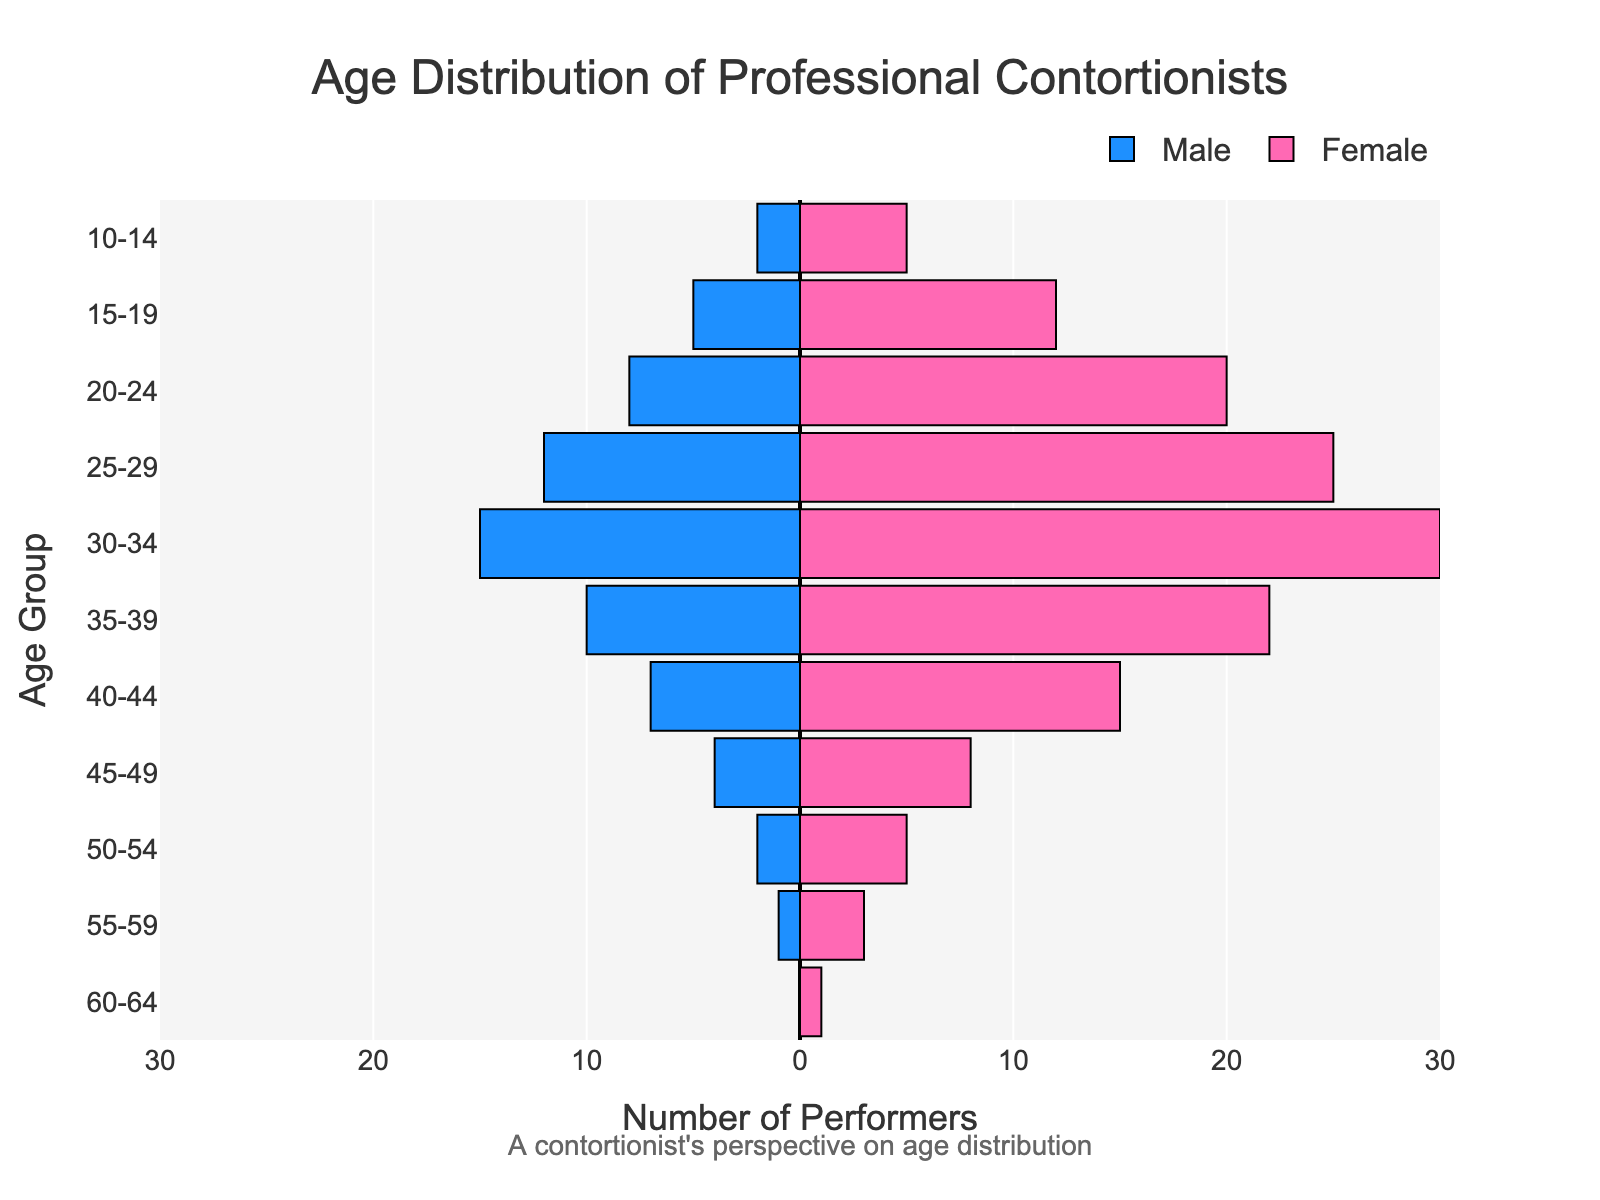What is the title of the figure? The title of the figure is usually located at the top and is specifically defined within the plot settings. In this case, it is listed as "Age Distribution of Professional Contortionists".
Answer: Age Distribution of Professional Contortionists What are the two colors used in the bars? The bars representing males and females are color-coded for easy differentiation. Males are colored in blue, while females are in pink.
Answer: Blue and pink Which age group has the highest number of female contortionists? By inspecting the height of the pink (female) bars, the 30-34 age group is the highest, indicating the largest number of female contortionists.
Answer: 30-34 In which age group is the number of female contortionists double the number of males? For each age group, check if the number of female contortionists is double the number of males. The 45-49 age group has 4 males and 8 females, which matches this criterion as 8 is exactly double 4.
Answer: 45-49 What is the total number of male contortionists in the 20-24 and 25-29 age groups? Add the number of males from both age groups: 8 (20-24) + 12 (25-29) = 20.
Answer: 20 Which gender has more contortionists aged 35-39? Compare the bar lengths for males and females in the 35-39 age group. The female bar is longer, representing 22 females compared to 10 males.
Answer: Female What is the median age group for male contortionists? To determine the median age group, find the age group where 50% of the male population is older and 50% younger. Given the quick visual binomial balance between younger (more than 50% below 30 years old) and middle-aged categories, the 30-34 age group stands as the central median point.
Answer: 30-34 How many age groups have more than 15 female contortionists? Count the age groups where the female bar is longer than 15 units. These are the 25-29, 30-34, and 35-39 groups.
Answer: 3 What is the difference in numbers between male and female contortionists aged 30-34? Subtract the number of males from the number of females in the 30-34 age group: 30 (female) - 15 (male) = 15.
Answer: 15 Which age group shows the lowest number of male contortionists? Locate the age group with the shortest blue bar representing males. The 60-64 age group has zero male contortionists.
Answer: 60-64 